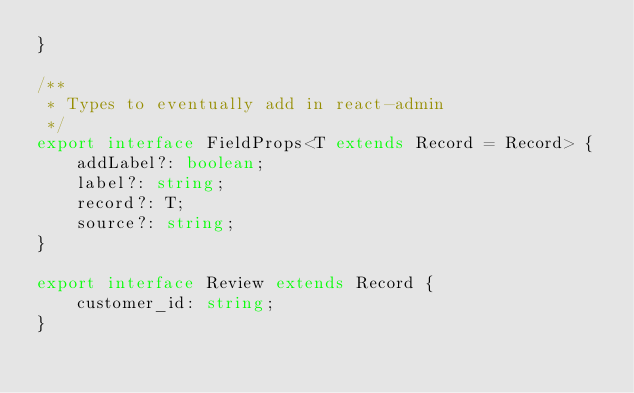Convert code to text. <code><loc_0><loc_0><loc_500><loc_500><_TypeScript_>}

/**
 * Types to eventually add in react-admin
 */
export interface FieldProps<T extends Record = Record> {
    addLabel?: boolean;
    label?: string;
    record?: T;
    source?: string;
}

export interface Review extends Record {
    customer_id: string;
}
</code> 